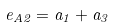<formula> <loc_0><loc_0><loc_500><loc_500>e _ { A 2 } = a _ { 1 } + a _ { 3 }</formula> 